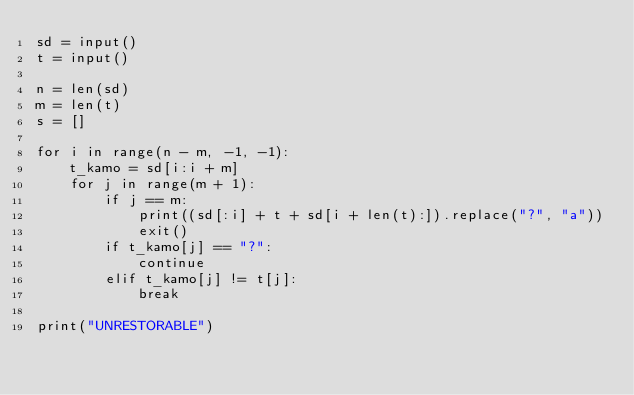Convert code to text. <code><loc_0><loc_0><loc_500><loc_500><_Python_>sd = input()
t = input()

n = len(sd)
m = len(t)
s = []

for i in range(n - m, -1, -1):
    t_kamo = sd[i:i + m]
    for j in range(m + 1):
        if j == m:
            print((sd[:i] + t + sd[i + len(t):]).replace("?", "a"))
            exit()
        if t_kamo[j] == "?":
            continue
        elif t_kamo[j] != t[j]:
            break

print("UNRESTORABLE")</code> 